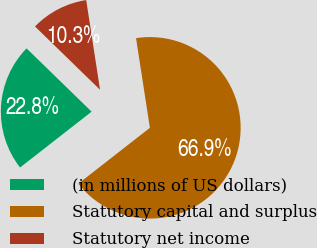Convert chart to OTSL. <chart><loc_0><loc_0><loc_500><loc_500><pie_chart><fcel>(in millions of US dollars)<fcel>Statutory capital and surplus<fcel>Statutory net income<nl><fcel>22.83%<fcel>66.89%<fcel>10.28%<nl></chart> 